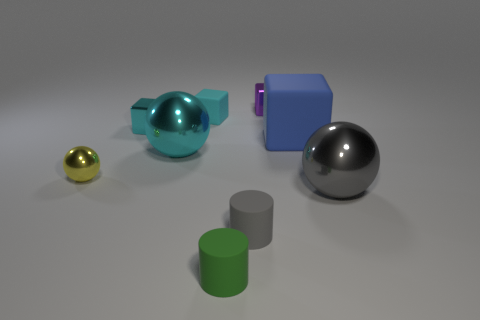What number of other things are the same shape as the cyan matte thing?
Provide a short and direct response. 3. The cyan metallic thing that is behind the big block has what shape?
Your answer should be very brief. Cube. Does the big metal thing behind the yellow sphere have the same shape as the tiny object that is in front of the gray matte object?
Your response must be concise. No. Is the number of small spheres in front of the yellow shiny object the same as the number of cyan rubber cubes?
Provide a short and direct response. No. Are there any other things that are the same size as the green object?
Provide a short and direct response. Yes. What material is the small purple thing that is the same shape as the big blue rubber object?
Offer a terse response. Metal. What shape is the big shiny thing on the left side of the large metal sphere that is right of the small green cylinder?
Ensure brevity in your answer.  Sphere. Is the material of the small thing that is behind the cyan matte object the same as the big block?
Offer a terse response. No. Are there the same number of gray cylinders right of the small purple shiny cube and gray shiny objects behind the gray cylinder?
Provide a succinct answer. No. There is a big object that is the same color as the tiny matte block; what material is it?
Keep it short and to the point. Metal. 